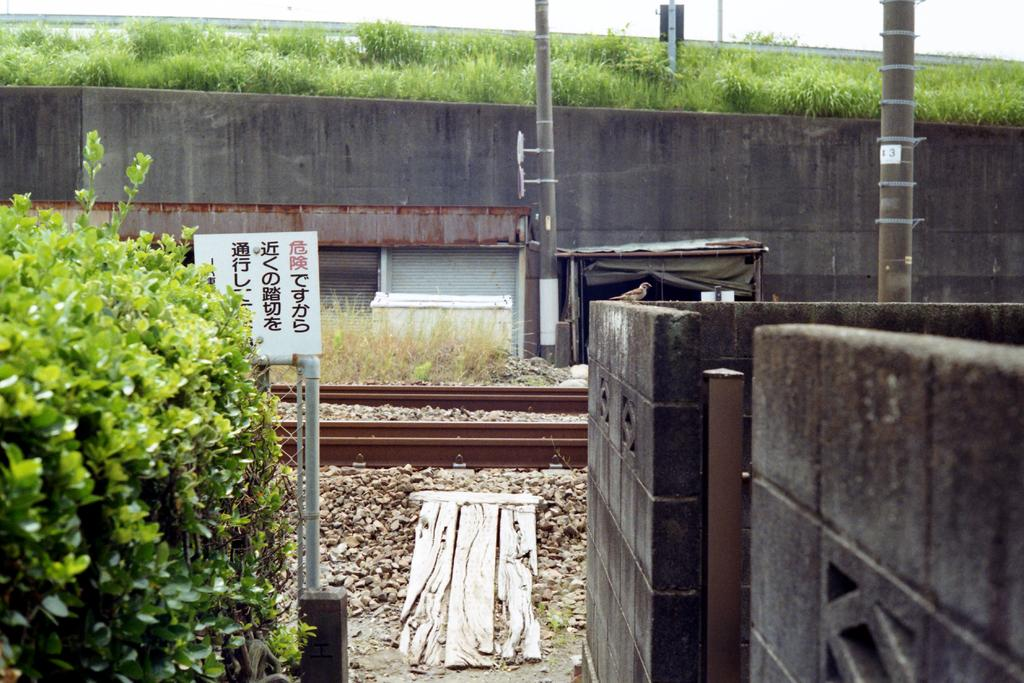What type of transportation infrastructure is visible in the image? There is a railway track in the image. What other structures can be seen in the image? There are poles and a wall visible in the image. What type of vegetation is present in the image? There is grass and bushes in the image. Where is the wall located in the image? There is a wall in the foreground of the image. In which direction does the power flow in the image? There is no indication of power flow in the image, as it does not contain any electrical infrastructure. What is the image's orientation in relation to the north? The image's orientation in relation to the north cannot be determined from the image itself. 